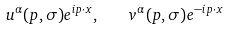<formula> <loc_0><loc_0><loc_500><loc_500>u ^ { \alpha } ( p , \sigma ) e ^ { i p \cdot x } , \quad v ^ { \alpha } ( p , \sigma ) e ^ { - i p \cdot x }</formula> 